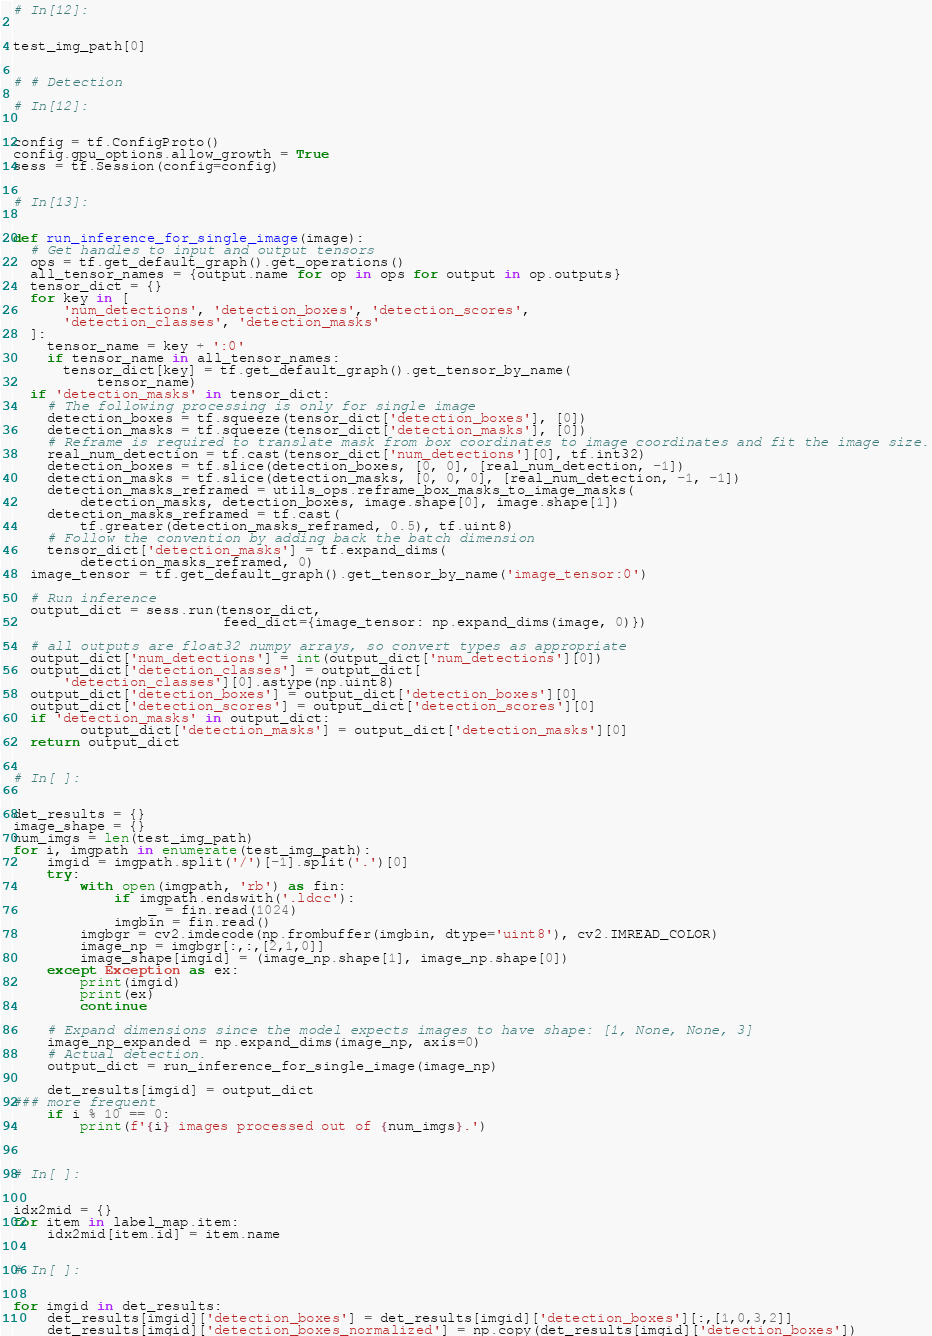<code> <loc_0><loc_0><loc_500><loc_500><_Python_>

# In[12]:


test_img_path[0]


# # Detection

# In[12]:


config = tf.ConfigProto()
config.gpu_options.allow_growth = True
sess = tf.Session(config=config)


# In[13]:


def run_inference_for_single_image(image):
  # Get handles to input and output tensors
  ops = tf.get_default_graph().get_operations()
  all_tensor_names = {output.name for op in ops for output in op.outputs}
  tensor_dict = {}
  for key in [
      'num_detections', 'detection_boxes', 'detection_scores',
      'detection_classes', 'detection_masks'
  ]:
    tensor_name = key + ':0'
    if tensor_name in all_tensor_names:
      tensor_dict[key] = tf.get_default_graph().get_tensor_by_name(
          tensor_name)
  if 'detection_masks' in tensor_dict:
    # The following processing is only for single image
    detection_boxes = tf.squeeze(tensor_dict['detection_boxes'], [0])
    detection_masks = tf.squeeze(tensor_dict['detection_masks'], [0])
    # Reframe is required to translate mask from box coordinates to image coordinates and fit the image size.
    real_num_detection = tf.cast(tensor_dict['num_detections'][0], tf.int32)
    detection_boxes = tf.slice(detection_boxes, [0, 0], [real_num_detection, -1])
    detection_masks = tf.slice(detection_masks, [0, 0, 0], [real_num_detection, -1, -1])
    detection_masks_reframed = utils_ops.reframe_box_masks_to_image_masks(
        detection_masks, detection_boxes, image.shape[0], image.shape[1])
    detection_masks_reframed = tf.cast(
        tf.greater(detection_masks_reframed, 0.5), tf.uint8)
    # Follow the convention by adding back the batch dimension
    tensor_dict['detection_masks'] = tf.expand_dims(
        detection_masks_reframed, 0)
  image_tensor = tf.get_default_graph().get_tensor_by_name('image_tensor:0')

  # Run inference
  output_dict = sess.run(tensor_dict,
                         feed_dict={image_tensor: np.expand_dims(image, 0)})

  # all outputs are float32 numpy arrays, so convert types as appropriate
  output_dict['num_detections'] = int(output_dict['num_detections'][0])
  output_dict['detection_classes'] = output_dict[
      'detection_classes'][0].astype(np.uint8)
  output_dict['detection_boxes'] = output_dict['detection_boxes'][0]
  output_dict['detection_scores'] = output_dict['detection_scores'][0]
  if 'detection_masks' in output_dict:
        output_dict['detection_masks'] = output_dict['detection_masks'][0]
  return output_dict


# In[ ]:


det_results = {}
image_shape = {}
num_imgs = len(test_img_path)
for i, imgpath in enumerate(test_img_path):
    imgid = imgpath.split('/')[-1].split('.')[0]
    try:
        with open(imgpath, 'rb') as fin:
            if imgpath.endswith('.ldcc'):
                _ = fin.read(1024)
            imgbin = fin.read()
        imgbgr = cv2.imdecode(np.frombuffer(imgbin, dtype='uint8'), cv2.IMREAD_COLOR)
        image_np = imgbgr[:,:,[2,1,0]]
        image_shape[imgid] = (image_np.shape[1], image_np.shape[0])
    except Exception as ex:
        print(imgid)
        print(ex)
        continue
    
    # Expand dimensions since the model expects images to have shape: [1, None, None, 3]
    image_np_expanded = np.expand_dims(image_np, axis=0)
    # Actual detection.
    output_dict = run_inference_for_single_image(image_np)
    
    det_results[imgid] = output_dict
### more frequent    
    if i % 10 == 0:
        print(f'{i} images processed out of {num_imgs}.')
    


# In[ ]:


idx2mid = {}
for item in label_map.item:
    idx2mid[item.id] = item.name


# In[ ]:


for imgid in det_results:
    det_results[imgid]['detection_boxes'] = det_results[imgid]['detection_boxes'][:,[1,0,3,2]]
    det_results[imgid]['detection_boxes_normalized'] = np.copy(det_results[imgid]['detection_boxes'])</code> 